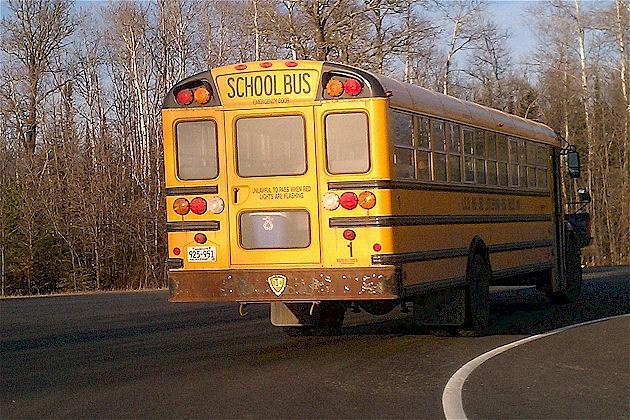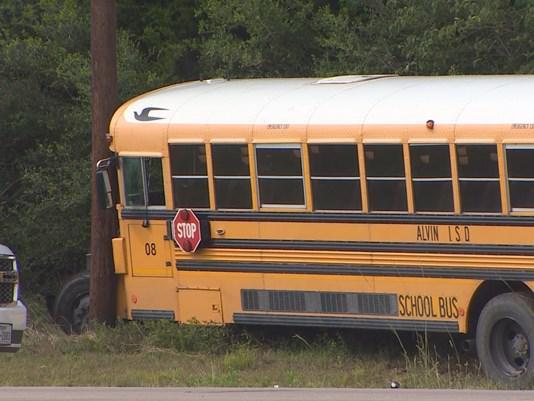The first image is the image on the left, the second image is the image on the right. Analyze the images presented: Is the assertion "There are two school buses in total." valid? Answer yes or no. Yes. The first image is the image on the left, the second image is the image on the right. Analyze the images presented: Is the assertion "Exactly two buses are visible." valid? Answer yes or no. Yes. 